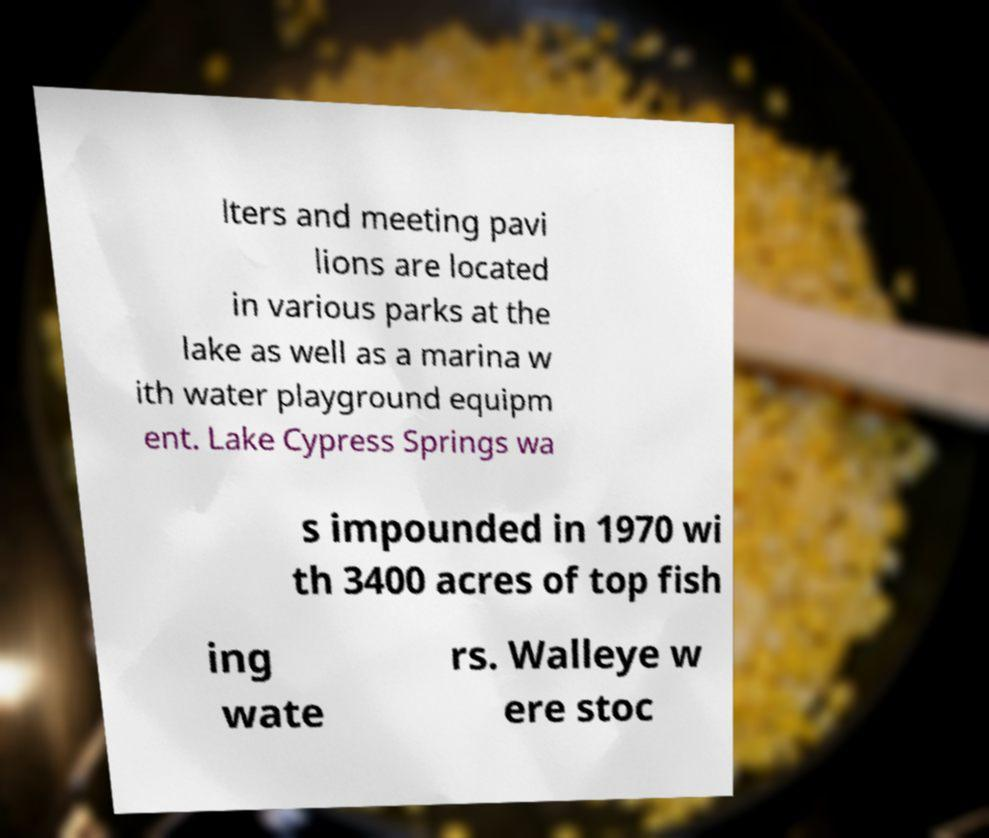I need the written content from this picture converted into text. Can you do that? lters and meeting pavi lions are located in various parks at the lake as well as a marina w ith water playground equipm ent. Lake Cypress Springs wa s impounded in 1970 wi th 3400 acres of top fish ing wate rs. Walleye w ere stoc 